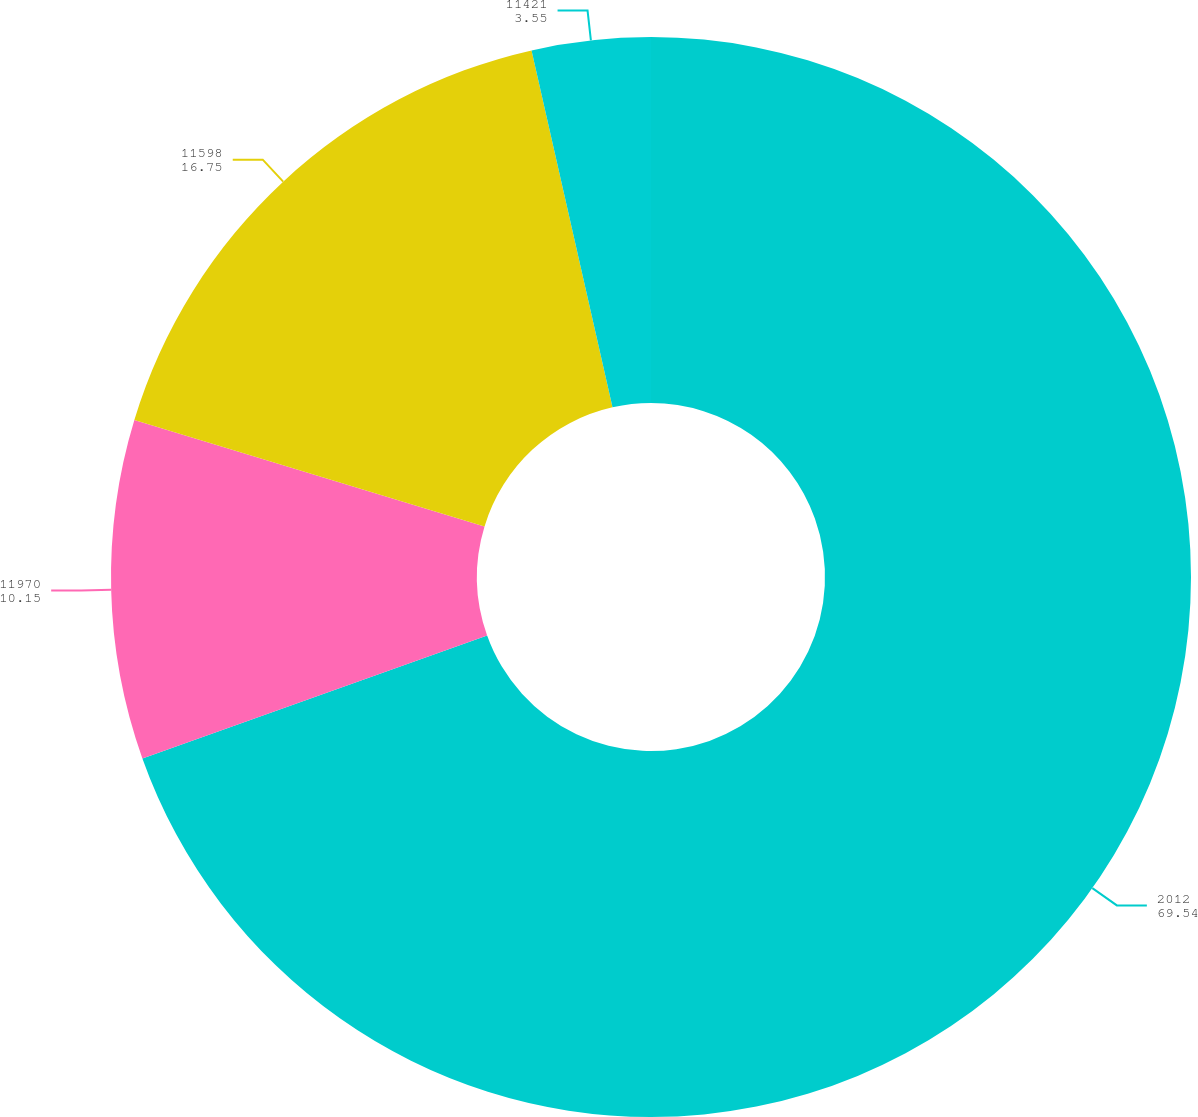Convert chart to OTSL. <chart><loc_0><loc_0><loc_500><loc_500><pie_chart><fcel>2012<fcel>11970<fcel>11598<fcel>11421<nl><fcel>69.54%<fcel>10.15%<fcel>16.75%<fcel>3.55%<nl></chart> 